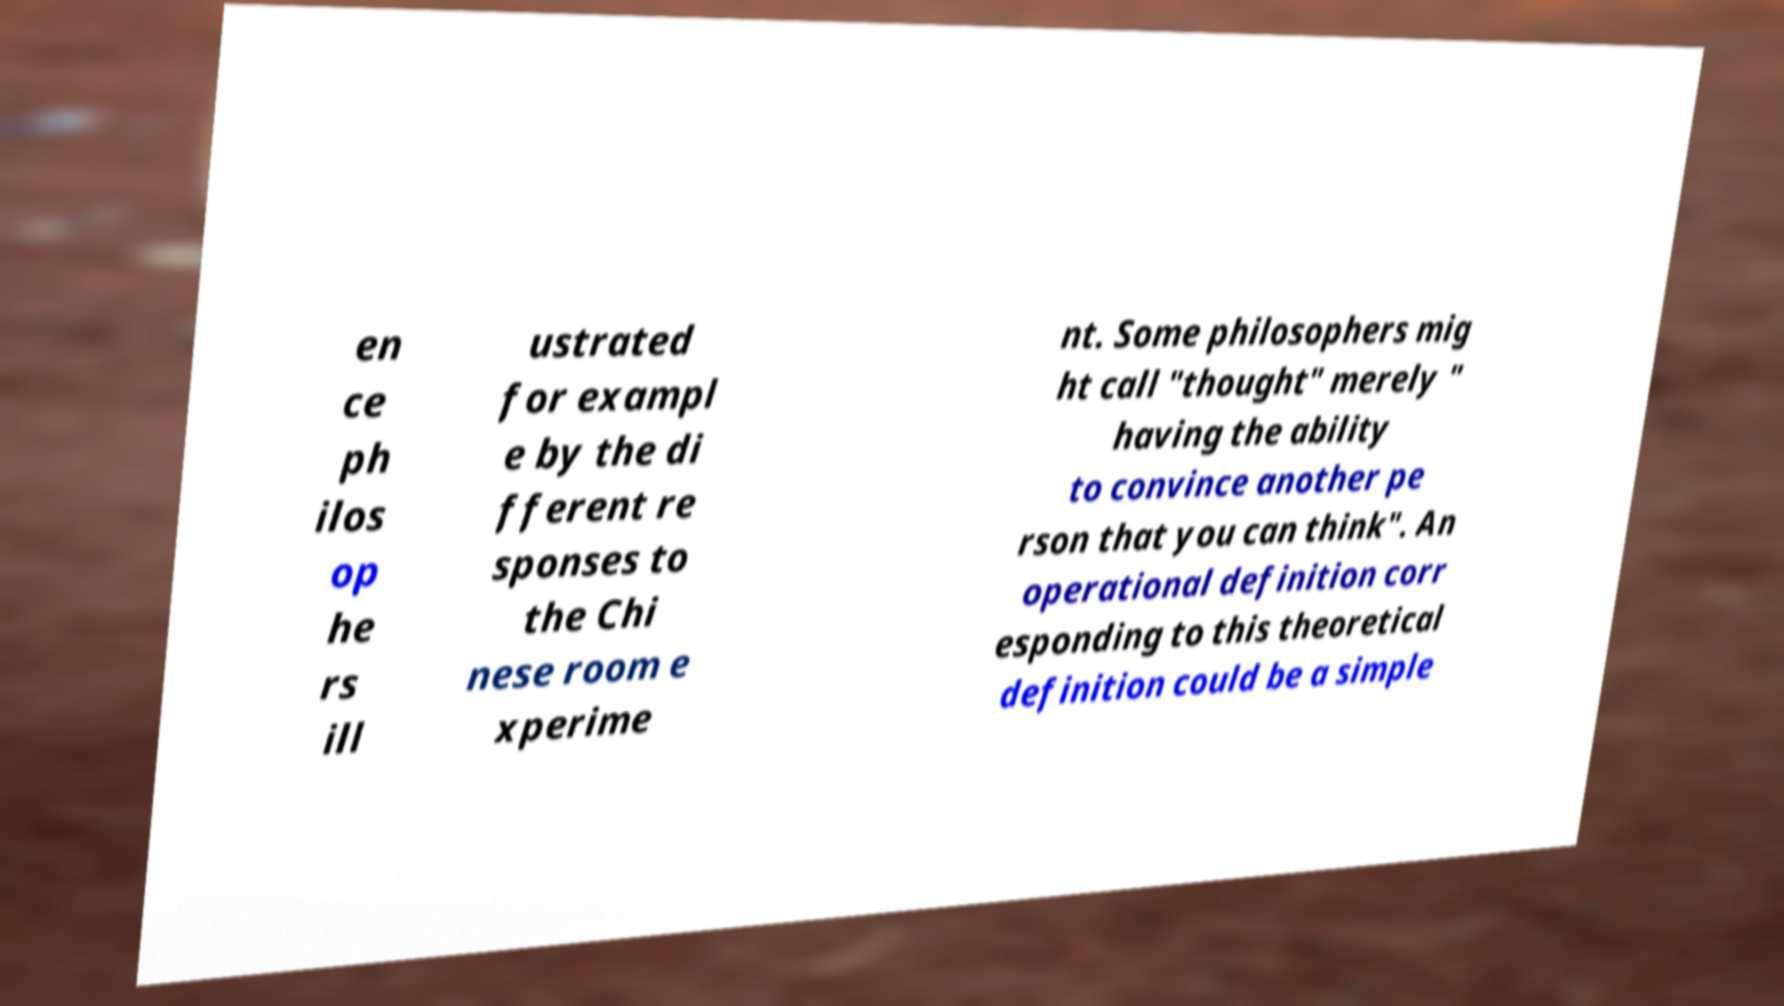Can you read and provide the text displayed in the image?This photo seems to have some interesting text. Can you extract and type it out for me? en ce ph ilos op he rs ill ustrated for exampl e by the di fferent re sponses to the Chi nese room e xperime nt. Some philosophers mig ht call "thought" merely " having the ability to convince another pe rson that you can think". An operational definition corr esponding to this theoretical definition could be a simple 